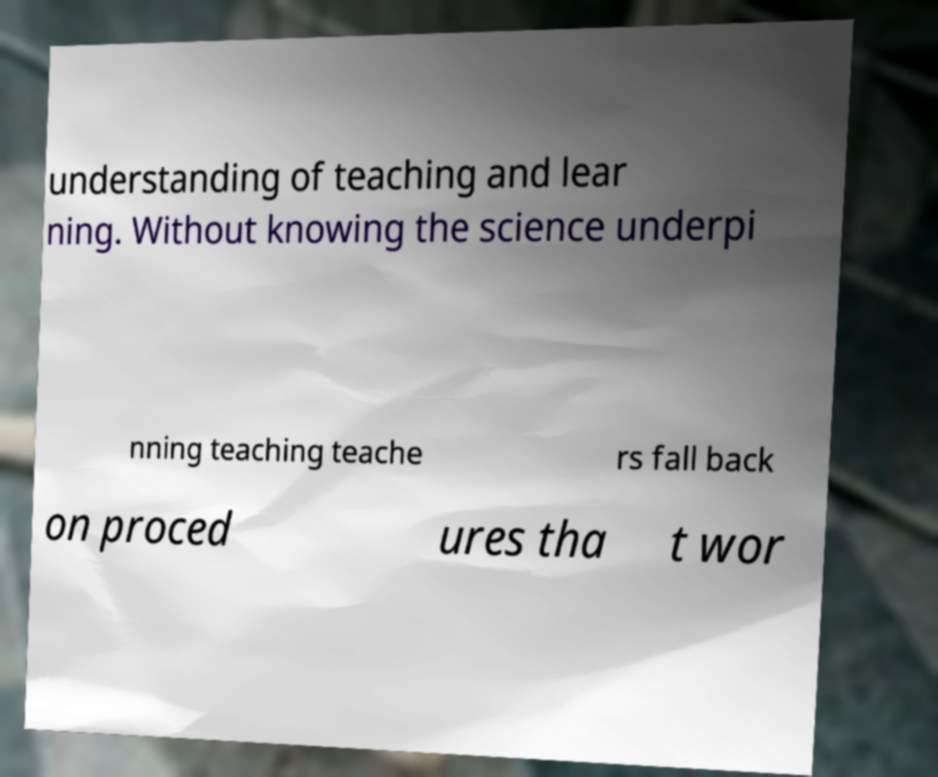Can you accurately transcribe the text from the provided image for me? understanding of teaching and lear ning. Without knowing the science underpi nning teaching teache rs fall back on proced ures tha t wor 